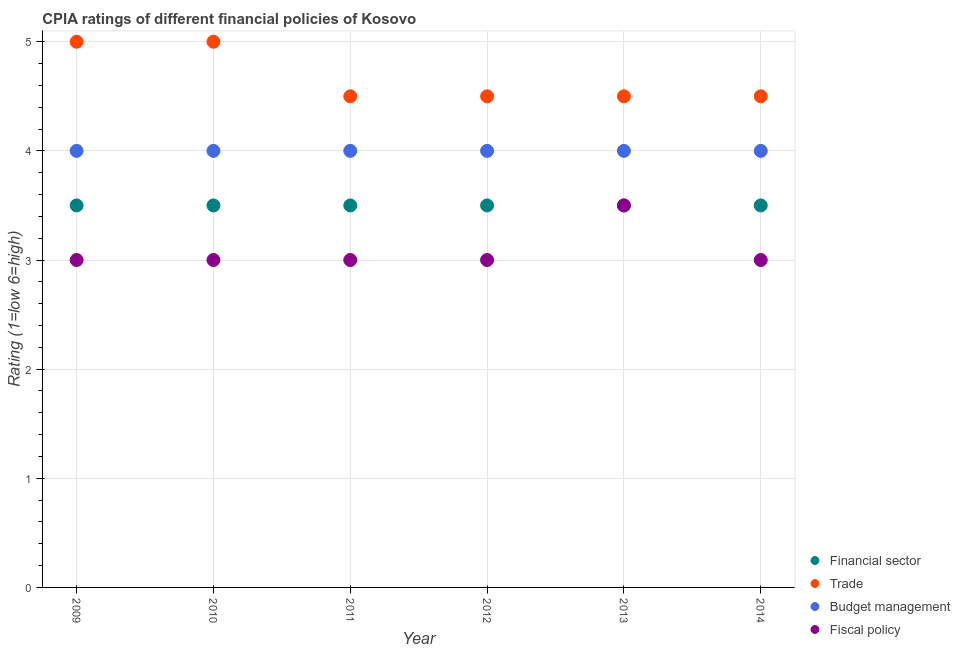How many different coloured dotlines are there?
Keep it short and to the point. 4. Is the number of dotlines equal to the number of legend labels?
Ensure brevity in your answer.  Yes. Across all years, what is the maximum cpia rating of fiscal policy?
Keep it short and to the point. 3.5. Across all years, what is the minimum cpia rating of trade?
Your response must be concise. 4.5. In which year was the cpia rating of trade maximum?
Ensure brevity in your answer.  2009. What is the total cpia rating of budget management in the graph?
Your answer should be compact. 24. What is the difference between the cpia rating of trade in 2011 and that in 2014?
Offer a terse response. 0. What is the difference between the cpia rating of trade in 2010 and the cpia rating of fiscal policy in 2012?
Give a very brief answer. 2. What is the average cpia rating of fiscal policy per year?
Your answer should be very brief. 3.08. In how many years, is the cpia rating of budget management greater than 0.8?
Offer a very short reply. 6. What is the ratio of the cpia rating of budget management in 2009 to that in 2011?
Provide a succinct answer. 1. Is the cpia rating of fiscal policy in 2010 less than that in 2013?
Keep it short and to the point. Yes. What is the difference between the highest and the second highest cpia rating of fiscal policy?
Offer a very short reply. 0.5. Is the sum of the cpia rating of budget management in 2010 and 2012 greater than the maximum cpia rating of financial sector across all years?
Provide a succinct answer. Yes. Is it the case that in every year, the sum of the cpia rating of budget management and cpia rating of fiscal policy is greater than the sum of cpia rating of trade and cpia rating of financial sector?
Give a very brief answer. No. Is it the case that in every year, the sum of the cpia rating of financial sector and cpia rating of trade is greater than the cpia rating of budget management?
Give a very brief answer. Yes. Does the cpia rating of budget management monotonically increase over the years?
Your response must be concise. No. Is the cpia rating of fiscal policy strictly less than the cpia rating of budget management over the years?
Offer a terse response. Yes. How many legend labels are there?
Ensure brevity in your answer.  4. What is the title of the graph?
Ensure brevity in your answer.  CPIA ratings of different financial policies of Kosovo. Does "Forest" appear as one of the legend labels in the graph?
Offer a terse response. No. What is the Rating (1=low 6=high) in Financial sector in 2009?
Offer a very short reply. 3.5. What is the Rating (1=low 6=high) of Trade in 2009?
Your response must be concise. 5. What is the Rating (1=low 6=high) of Fiscal policy in 2009?
Your answer should be compact. 3. What is the Rating (1=low 6=high) of Budget management in 2010?
Ensure brevity in your answer.  4. What is the Rating (1=low 6=high) in Financial sector in 2011?
Give a very brief answer. 3.5. What is the Rating (1=low 6=high) of Financial sector in 2012?
Give a very brief answer. 3.5. What is the Rating (1=low 6=high) in Trade in 2012?
Give a very brief answer. 4.5. What is the Rating (1=low 6=high) in Fiscal policy in 2013?
Your answer should be very brief. 3.5. What is the Rating (1=low 6=high) in Budget management in 2014?
Offer a terse response. 4. What is the Rating (1=low 6=high) of Fiscal policy in 2014?
Offer a terse response. 3. Across all years, what is the maximum Rating (1=low 6=high) in Trade?
Keep it short and to the point. 5. Across all years, what is the minimum Rating (1=low 6=high) in Trade?
Your response must be concise. 4.5. Across all years, what is the minimum Rating (1=low 6=high) in Budget management?
Make the answer very short. 4. What is the total Rating (1=low 6=high) of Financial sector in the graph?
Ensure brevity in your answer.  21. What is the total Rating (1=low 6=high) of Budget management in the graph?
Your answer should be compact. 24. What is the difference between the Rating (1=low 6=high) of Financial sector in 2009 and that in 2010?
Your answer should be very brief. 0. What is the difference between the Rating (1=low 6=high) of Trade in 2009 and that in 2010?
Offer a terse response. 0. What is the difference between the Rating (1=low 6=high) of Budget management in 2009 and that in 2010?
Make the answer very short. 0. What is the difference between the Rating (1=low 6=high) of Financial sector in 2009 and that in 2011?
Your answer should be very brief. 0. What is the difference between the Rating (1=low 6=high) of Trade in 2009 and that in 2011?
Keep it short and to the point. 0.5. What is the difference between the Rating (1=low 6=high) in Financial sector in 2009 and that in 2012?
Your answer should be very brief. 0. What is the difference between the Rating (1=low 6=high) of Trade in 2009 and that in 2012?
Ensure brevity in your answer.  0.5. What is the difference between the Rating (1=low 6=high) in Budget management in 2009 and that in 2012?
Provide a succinct answer. 0. What is the difference between the Rating (1=low 6=high) in Fiscal policy in 2009 and that in 2012?
Provide a short and direct response. 0. What is the difference between the Rating (1=low 6=high) in Financial sector in 2009 and that in 2013?
Your response must be concise. 0. What is the difference between the Rating (1=low 6=high) in Trade in 2009 and that in 2013?
Make the answer very short. 0.5. What is the difference between the Rating (1=low 6=high) in Budget management in 2009 and that in 2013?
Your response must be concise. 0. What is the difference between the Rating (1=low 6=high) of Financial sector in 2009 and that in 2014?
Ensure brevity in your answer.  0. What is the difference between the Rating (1=low 6=high) in Trade in 2009 and that in 2014?
Give a very brief answer. 0.5. What is the difference between the Rating (1=low 6=high) of Fiscal policy in 2010 and that in 2011?
Your answer should be compact. 0. What is the difference between the Rating (1=low 6=high) of Trade in 2010 and that in 2012?
Your answer should be compact. 0.5. What is the difference between the Rating (1=low 6=high) of Fiscal policy in 2010 and that in 2012?
Give a very brief answer. 0. What is the difference between the Rating (1=low 6=high) in Financial sector in 2010 and that in 2013?
Offer a very short reply. 0. What is the difference between the Rating (1=low 6=high) of Trade in 2010 and that in 2013?
Keep it short and to the point. 0.5. What is the difference between the Rating (1=low 6=high) of Budget management in 2010 and that in 2013?
Offer a very short reply. 0. What is the difference between the Rating (1=low 6=high) of Fiscal policy in 2010 and that in 2013?
Offer a terse response. -0.5. What is the difference between the Rating (1=low 6=high) in Budget management in 2010 and that in 2014?
Give a very brief answer. 0. What is the difference between the Rating (1=low 6=high) of Fiscal policy in 2010 and that in 2014?
Ensure brevity in your answer.  0. What is the difference between the Rating (1=low 6=high) of Financial sector in 2011 and that in 2012?
Give a very brief answer. 0. What is the difference between the Rating (1=low 6=high) of Budget management in 2011 and that in 2012?
Make the answer very short. 0. What is the difference between the Rating (1=low 6=high) of Fiscal policy in 2011 and that in 2012?
Keep it short and to the point. 0. What is the difference between the Rating (1=low 6=high) of Trade in 2011 and that in 2013?
Your response must be concise. 0. What is the difference between the Rating (1=low 6=high) of Fiscal policy in 2011 and that in 2013?
Your answer should be very brief. -0.5. What is the difference between the Rating (1=low 6=high) of Trade in 2011 and that in 2014?
Ensure brevity in your answer.  0. What is the difference between the Rating (1=low 6=high) of Fiscal policy in 2011 and that in 2014?
Make the answer very short. 0. What is the difference between the Rating (1=low 6=high) of Financial sector in 2012 and that in 2013?
Give a very brief answer. 0. What is the difference between the Rating (1=low 6=high) of Trade in 2012 and that in 2013?
Provide a short and direct response. 0. What is the difference between the Rating (1=low 6=high) of Fiscal policy in 2012 and that in 2013?
Give a very brief answer. -0.5. What is the difference between the Rating (1=low 6=high) of Budget management in 2012 and that in 2014?
Give a very brief answer. 0. What is the difference between the Rating (1=low 6=high) in Financial sector in 2013 and that in 2014?
Offer a terse response. 0. What is the difference between the Rating (1=low 6=high) in Trade in 2013 and that in 2014?
Your answer should be very brief. 0. What is the difference between the Rating (1=low 6=high) in Budget management in 2013 and that in 2014?
Ensure brevity in your answer.  0. What is the difference between the Rating (1=low 6=high) in Fiscal policy in 2013 and that in 2014?
Make the answer very short. 0.5. What is the difference between the Rating (1=low 6=high) of Financial sector in 2009 and the Rating (1=low 6=high) of Budget management in 2010?
Your response must be concise. -0.5. What is the difference between the Rating (1=low 6=high) in Trade in 2009 and the Rating (1=low 6=high) in Budget management in 2010?
Ensure brevity in your answer.  1. What is the difference between the Rating (1=low 6=high) of Trade in 2009 and the Rating (1=low 6=high) of Fiscal policy in 2010?
Keep it short and to the point. 2. What is the difference between the Rating (1=low 6=high) in Budget management in 2009 and the Rating (1=low 6=high) in Fiscal policy in 2010?
Your answer should be compact. 1. What is the difference between the Rating (1=low 6=high) in Financial sector in 2009 and the Rating (1=low 6=high) in Trade in 2011?
Provide a short and direct response. -1. What is the difference between the Rating (1=low 6=high) of Financial sector in 2009 and the Rating (1=low 6=high) of Fiscal policy in 2011?
Make the answer very short. 0.5. What is the difference between the Rating (1=low 6=high) in Budget management in 2009 and the Rating (1=low 6=high) in Fiscal policy in 2011?
Make the answer very short. 1. What is the difference between the Rating (1=low 6=high) of Financial sector in 2009 and the Rating (1=low 6=high) of Trade in 2012?
Your answer should be very brief. -1. What is the difference between the Rating (1=low 6=high) in Financial sector in 2009 and the Rating (1=low 6=high) in Fiscal policy in 2012?
Provide a short and direct response. 0.5. What is the difference between the Rating (1=low 6=high) of Trade in 2009 and the Rating (1=low 6=high) of Fiscal policy in 2012?
Your response must be concise. 2. What is the difference between the Rating (1=low 6=high) of Budget management in 2009 and the Rating (1=low 6=high) of Fiscal policy in 2012?
Ensure brevity in your answer.  1. What is the difference between the Rating (1=low 6=high) in Financial sector in 2009 and the Rating (1=low 6=high) in Trade in 2013?
Offer a very short reply. -1. What is the difference between the Rating (1=low 6=high) in Trade in 2009 and the Rating (1=low 6=high) in Budget management in 2013?
Ensure brevity in your answer.  1. What is the difference between the Rating (1=low 6=high) in Financial sector in 2009 and the Rating (1=low 6=high) in Trade in 2014?
Your answer should be compact. -1. What is the difference between the Rating (1=low 6=high) in Financial sector in 2009 and the Rating (1=low 6=high) in Budget management in 2014?
Keep it short and to the point. -0.5. What is the difference between the Rating (1=low 6=high) of Budget management in 2009 and the Rating (1=low 6=high) of Fiscal policy in 2014?
Give a very brief answer. 1. What is the difference between the Rating (1=low 6=high) in Financial sector in 2010 and the Rating (1=low 6=high) in Trade in 2011?
Provide a succinct answer. -1. What is the difference between the Rating (1=low 6=high) in Financial sector in 2010 and the Rating (1=low 6=high) in Budget management in 2011?
Your response must be concise. -0.5. What is the difference between the Rating (1=low 6=high) in Financial sector in 2010 and the Rating (1=low 6=high) in Fiscal policy in 2011?
Provide a short and direct response. 0.5. What is the difference between the Rating (1=low 6=high) in Financial sector in 2010 and the Rating (1=low 6=high) in Budget management in 2012?
Your response must be concise. -0.5. What is the difference between the Rating (1=low 6=high) in Trade in 2010 and the Rating (1=low 6=high) in Budget management in 2012?
Your response must be concise. 1. What is the difference between the Rating (1=low 6=high) of Trade in 2010 and the Rating (1=low 6=high) of Fiscal policy in 2012?
Offer a terse response. 2. What is the difference between the Rating (1=low 6=high) of Financial sector in 2010 and the Rating (1=low 6=high) of Fiscal policy in 2013?
Ensure brevity in your answer.  0. What is the difference between the Rating (1=low 6=high) of Trade in 2010 and the Rating (1=low 6=high) of Budget management in 2013?
Keep it short and to the point. 1. What is the difference between the Rating (1=low 6=high) in Trade in 2010 and the Rating (1=low 6=high) in Fiscal policy in 2013?
Make the answer very short. 1.5. What is the difference between the Rating (1=low 6=high) of Budget management in 2010 and the Rating (1=low 6=high) of Fiscal policy in 2013?
Make the answer very short. 0.5. What is the difference between the Rating (1=low 6=high) of Financial sector in 2010 and the Rating (1=low 6=high) of Budget management in 2014?
Offer a terse response. -0.5. What is the difference between the Rating (1=low 6=high) in Trade in 2010 and the Rating (1=low 6=high) in Fiscal policy in 2014?
Offer a very short reply. 2. What is the difference between the Rating (1=low 6=high) of Financial sector in 2011 and the Rating (1=low 6=high) of Fiscal policy in 2012?
Provide a succinct answer. 0.5. What is the difference between the Rating (1=low 6=high) in Trade in 2011 and the Rating (1=low 6=high) in Budget management in 2012?
Give a very brief answer. 0.5. What is the difference between the Rating (1=low 6=high) of Trade in 2011 and the Rating (1=low 6=high) of Fiscal policy in 2012?
Provide a succinct answer. 1.5. What is the difference between the Rating (1=low 6=high) in Budget management in 2011 and the Rating (1=low 6=high) in Fiscal policy in 2012?
Your response must be concise. 1. What is the difference between the Rating (1=low 6=high) of Financial sector in 2011 and the Rating (1=low 6=high) of Trade in 2013?
Provide a succinct answer. -1. What is the difference between the Rating (1=low 6=high) of Financial sector in 2011 and the Rating (1=low 6=high) of Budget management in 2013?
Your answer should be very brief. -0.5. What is the difference between the Rating (1=low 6=high) of Trade in 2011 and the Rating (1=low 6=high) of Fiscal policy in 2013?
Provide a succinct answer. 1. What is the difference between the Rating (1=low 6=high) of Budget management in 2011 and the Rating (1=low 6=high) of Fiscal policy in 2013?
Your answer should be compact. 0.5. What is the difference between the Rating (1=low 6=high) in Financial sector in 2011 and the Rating (1=low 6=high) in Budget management in 2014?
Your response must be concise. -0.5. What is the difference between the Rating (1=low 6=high) of Financial sector in 2011 and the Rating (1=low 6=high) of Fiscal policy in 2014?
Your response must be concise. 0.5. What is the difference between the Rating (1=low 6=high) of Trade in 2011 and the Rating (1=low 6=high) of Budget management in 2014?
Your response must be concise. 0.5. What is the difference between the Rating (1=low 6=high) in Trade in 2011 and the Rating (1=low 6=high) in Fiscal policy in 2014?
Offer a very short reply. 1.5. What is the difference between the Rating (1=low 6=high) of Financial sector in 2012 and the Rating (1=low 6=high) of Budget management in 2013?
Offer a very short reply. -0.5. What is the difference between the Rating (1=low 6=high) in Trade in 2012 and the Rating (1=low 6=high) in Budget management in 2013?
Make the answer very short. 0.5. What is the difference between the Rating (1=low 6=high) of Trade in 2012 and the Rating (1=low 6=high) of Fiscal policy in 2013?
Your answer should be compact. 1. What is the difference between the Rating (1=low 6=high) in Financial sector in 2012 and the Rating (1=low 6=high) in Fiscal policy in 2014?
Give a very brief answer. 0.5. What is the difference between the Rating (1=low 6=high) of Trade in 2012 and the Rating (1=low 6=high) of Fiscal policy in 2014?
Keep it short and to the point. 1.5. What is the difference between the Rating (1=low 6=high) in Budget management in 2012 and the Rating (1=low 6=high) in Fiscal policy in 2014?
Make the answer very short. 1. What is the difference between the Rating (1=low 6=high) in Financial sector in 2013 and the Rating (1=low 6=high) in Budget management in 2014?
Ensure brevity in your answer.  -0.5. What is the difference between the Rating (1=low 6=high) of Financial sector in 2013 and the Rating (1=low 6=high) of Fiscal policy in 2014?
Provide a short and direct response. 0.5. What is the difference between the Rating (1=low 6=high) in Trade in 2013 and the Rating (1=low 6=high) in Budget management in 2014?
Provide a short and direct response. 0.5. What is the difference between the Rating (1=low 6=high) of Budget management in 2013 and the Rating (1=low 6=high) of Fiscal policy in 2014?
Provide a succinct answer. 1. What is the average Rating (1=low 6=high) of Trade per year?
Provide a short and direct response. 4.67. What is the average Rating (1=low 6=high) in Budget management per year?
Offer a very short reply. 4. What is the average Rating (1=low 6=high) of Fiscal policy per year?
Offer a very short reply. 3.08. In the year 2009, what is the difference between the Rating (1=low 6=high) of Financial sector and Rating (1=low 6=high) of Budget management?
Make the answer very short. -0.5. In the year 2009, what is the difference between the Rating (1=low 6=high) in Trade and Rating (1=low 6=high) in Fiscal policy?
Provide a succinct answer. 2. In the year 2010, what is the difference between the Rating (1=low 6=high) of Financial sector and Rating (1=low 6=high) of Fiscal policy?
Provide a short and direct response. 0.5. In the year 2010, what is the difference between the Rating (1=low 6=high) in Trade and Rating (1=low 6=high) in Fiscal policy?
Offer a very short reply. 2. In the year 2010, what is the difference between the Rating (1=low 6=high) of Budget management and Rating (1=low 6=high) of Fiscal policy?
Make the answer very short. 1. In the year 2011, what is the difference between the Rating (1=low 6=high) in Financial sector and Rating (1=low 6=high) in Trade?
Provide a short and direct response. -1. In the year 2011, what is the difference between the Rating (1=low 6=high) of Financial sector and Rating (1=low 6=high) of Budget management?
Keep it short and to the point. -0.5. In the year 2011, what is the difference between the Rating (1=low 6=high) in Budget management and Rating (1=low 6=high) in Fiscal policy?
Your answer should be very brief. 1. In the year 2012, what is the difference between the Rating (1=low 6=high) of Financial sector and Rating (1=low 6=high) of Trade?
Make the answer very short. -1. In the year 2012, what is the difference between the Rating (1=low 6=high) in Financial sector and Rating (1=low 6=high) in Budget management?
Provide a succinct answer. -0.5. In the year 2012, what is the difference between the Rating (1=low 6=high) of Financial sector and Rating (1=low 6=high) of Fiscal policy?
Make the answer very short. 0.5. In the year 2012, what is the difference between the Rating (1=low 6=high) of Trade and Rating (1=low 6=high) of Budget management?
Your answer should be very brief. 0.5. In the year 2012, what is the difference between the Rating (1=low 6=high) of Trade and Rating (1=low 6=high) of Fiscal policy?
Your response must be concise. 1.5. In the year 2013, what is the difference between the Rating (1=low 6=high) of Financial sector and Rating (1=low 6=high) of Fiscal policy?
Your answer should be compact. 0. In the year 2013, what is the difference between the Rating (1=low 6=high) of Budget management and Rating (1=low 6=high) of Fiscal policy?
Provide a short and direct response. 0.5. In the year 2014, what is the difference between the Rating (1=low 6=high) in Financial sector and Rating (1=low 6=high) in Trade?
Provide a succinct answer. -1. In the year 2014, what is the difference between the Rating (1=low 6=high) of Financial sector and Rating (1=low 6=high) of Fiscal policy?
Your response must be concise. 0.5. In the year 2014, what is the difference between the Rating (1=low 6=high) of Trade and Rating (1=low 6=high) of Budget management?
Provide a succinct answer. 0.5. What is the ratio of the Rating (1=low 6=high) in Trade in 2009 to that in 2010?
Offer a terse response. 1. What is the ratio of the Rating (1=low 6=high) of Budget management in 2009 to that in 2010?
Ensure brevity in your answer.  1. What is the ratio of the Rating (1=low 6=high) in Financial sector in 2009 to that in 2012?
Your answer should be very brief. 1. What is the ratio of the Rating (1=low 6=high) of Budget management in 2009 to that in 2012?
Keep it short and to the point. 1. What is the ratio of the Rating (1=low 6=high) of Fiscal policy in 2009 to that in 2012?
Provide a succinct answer. 1. What is the ratio of the Rating (1=low 6=high) of Financial sector in 2009 to that in 2013?
Offer a very short reply. 1. What is the ratio of the Rating (1=low 6=high) in Trade in 2009 to that in 2013?
Provide a succinct answer. 1.11. What is the ratio of the Rating (1=low 6=high) in Financial sector in 2009 to that in 2014?
Your answer should be compact. 1. What is the ratio of the Rating (1=low 6=high) of Trade in 2009 to that in 2014?
Provide a short and direct response. 1.11. What is the ratio of the Rating (1=low 6=high) of Budget management in 2009 to that in 2014?
Your answer should be very brief. 1. What is the ratio of the Rating (1=low 6=high) of Trade in 2010 to that in 2011?
Your response must be concise. 1.11. What is the ratio of the Rating (1=low 6=high) in Budget management in 2010 to that in 2011?
Make the answer very short. 1. What is the ratio of the Rating (1=low 6=high) of Fiscal policy in 2010 to that in 2011?
Your answer should be compact. 1. What is the ratio of the Rating (1=low 6=high) of Trade in 2010 to that in 2012?
Ensure brevity in your answer.  1.11. What is the ratio of the Rating (1=low 6=high) of Budget management in 2010 to that in 2012?
Ensure brevity in your answer.  1. What is the ratio of the Rating (1=low 6=high) in Fiscal policy in 2010 to that in 2013?
Keep it short and to the point. 0.86. What is the ratio of the Rating (1=low 6=high) in Budget management in 2010 to that in 2014?
Your answer should be compact. 1. What is the ratio of the Rating (1=low 6=high) in Trade in 2011 to that in 2012?
Ensure brevity in your answer.  1. What is the ratio of the Rating (1=low 6=high) in Financial sector in 2011 to that in 2013?
Your answer should be compact. 1. What is the ratio of the Rating (1=low 6=high) of Trade in 2011 to that in 2013?
Offer a terse response. 1. What is the ratio of the Rating (1=low 6=high) in Budget management in 2011 to that in 2013?
Your answer should be compact. 1. What is the ratio of the Rating (1=low 6=high) of Fiscal policy in 2011 to that in 2013?
Give a very brief answer. 0.86. What is the ratio of the Rating (1=low 6=high) of Financial sector in 2011 to that in 2014?
Your response must be concise. 1. What is the ratio of the Rating (1=low 6=high) in Fiscal policy in 2011 to that in 2014?
Your answer should be very brief. 1. What is the ratio of the Rating (1=low 6=high) in Financial sector in 2012 to that in 2013?
Your answer should be compact. 1. What is the ratio of the Rating (1=low 6=high) of Trade in 2012 to that in 2013?
Your response must be concise. 1. What is the ratio of the Rating (1=low 6=high) in Budget management in 2012 to that in 2013?
Give a very brief answer. 1. What is the ratio of the Rating (1=low 6=high) of Fiscal policy in 2012 to that in 2013?
Make the answer very short. 0.86. What is the ratio of the Rating (1=low 6=high) of Financial sector in 2012 to that in 2014?
Offer a very short reply. 1. What is the ratio of the Rating (1=low 6=high) of Budget management in 2012 to that in 2014?
Make the answer very short. 1. What is the ratio of the Rating (1=low 6=high) in Fiscal policy in 2012 to that in 2014?
Offer a terse response. 1. What is the ratio of the Rating (1=low 6=high) in Trade in 2013 to that in 2014?
Give a very brief answer. 1. What is the ratio of the Rating (1=low 6=high) in Budget management in 2013 to that in 2014?
Provide a succinct answer. 1. What is the difference between the highest and the second highest Rating (1=low 6=high) of Budget management?
Your answer should be compact. 0. What is the difference between the highest and the second highest Rating (1=low 6=high) of Fiscal policy?
Offer a very short reply. 0.5. What is the difference between the highest and the lowest Rating (1=low 6=high) in Trade?
Keep it short and to the point. 0.5. What is the difference between the highest and the lowest Rating (1=low 6=high) of Budget management?
Offer a terse response. 0. What is the difference between the highest and the lowest Rating (1=low 6=high) in Fiscal policy?
Your response must be concise. 0.5. 